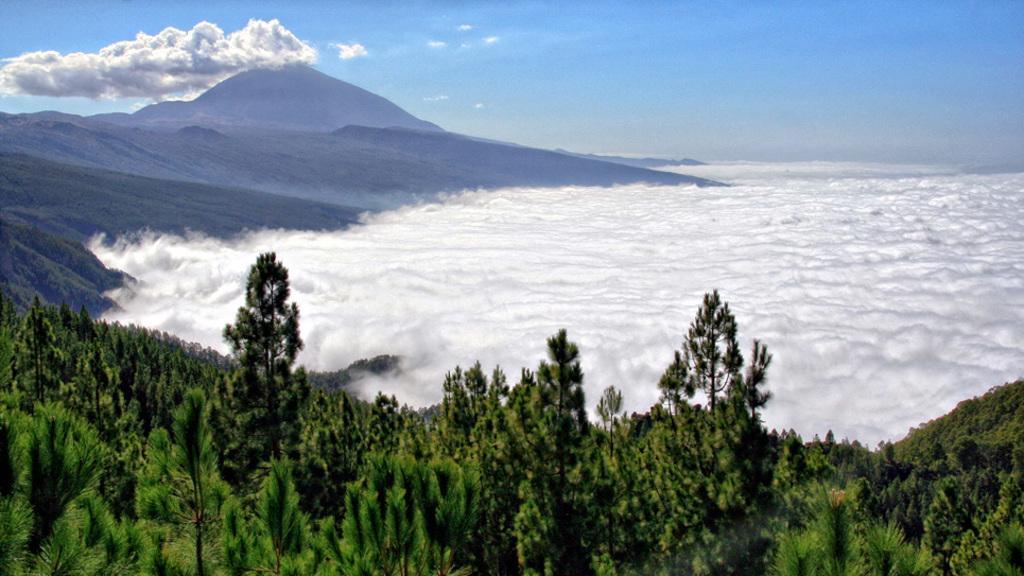In one or two sentences, can you explain what this image depicts? Here we can see trees, clouds, and a mountain. In the background there is sky. 